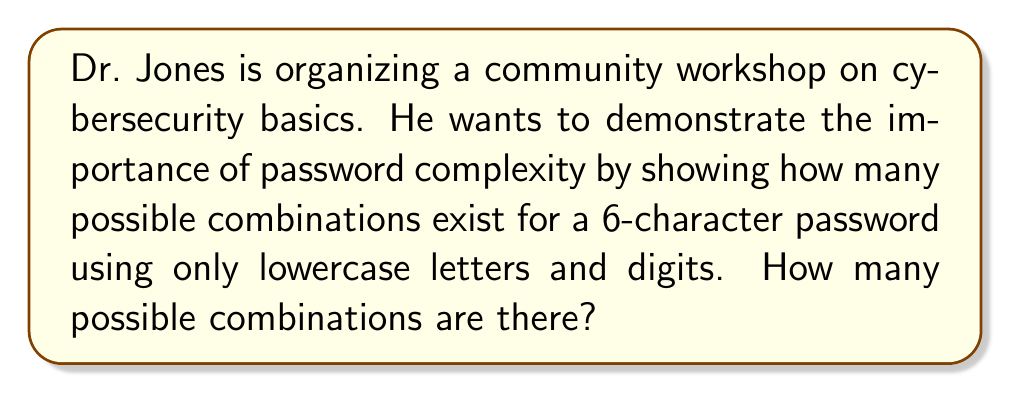Teach me how to tackle this problem. Let's approach this step-by-step:

1) First, we need to determine the number of possible characters for each position in the password:
   - There are 26 lowercase letters (a-z)
   - There are 10 digits (0-9)
   - In total, there are 26 + 10 = 36 possible characters for each position

2) Now, we need to consider how many positions there are in the password:
   - The password is 6 characters long

3) For each position, we have 36 choices, and this is true for all 6 positions. This is a case of the multiplication principle.

4) The total number of possible combinations is therefore:

   $$ 36 \times 36 \times 36 \times 36 \times 36 \times 36 = 36^6 $$

5) Let's calculate this:
   $$ 36^6 = 2,176,782,336 $$

Therefore, there are 2,176,782,336 possible combinations for a 6-character password using lowercase letters and digits.
Answer: $2,176,782,336$ 